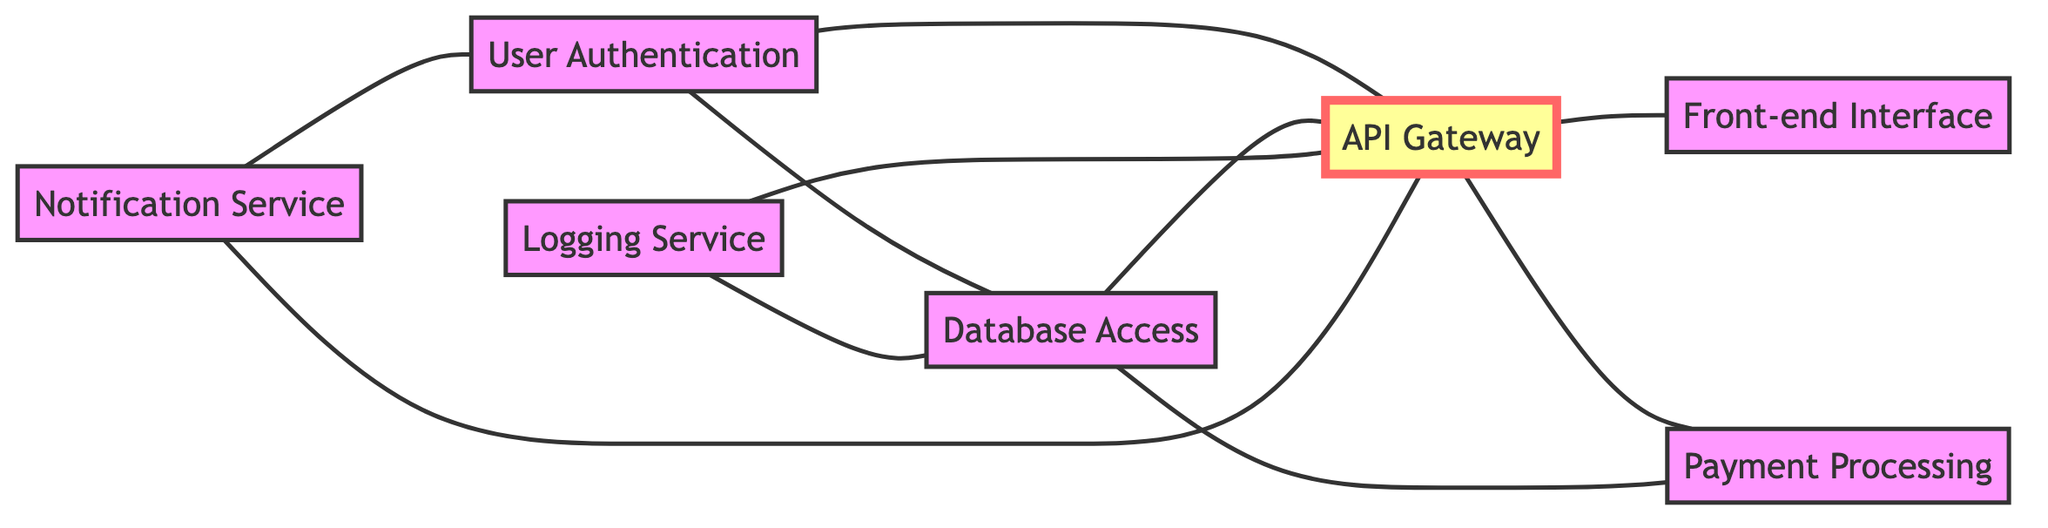What is the total number of nodes in the diagram? By counting the nodes listed in the data, we see that there are seven distinct modules: User Authentication, Database Access, API Gateway, Front-end Interface, Payment Processing, Logging Service, and Notification Service. Therefore, the total number of nodes is 7.
Answer: 7 Which module does the API Gateway connect to directly? Inspecting the connected edges to the API Gateway (ModuleC), we can see it connects directly to User Authentication (ModuleA), Database Access (ModuleB), Front-end Interface (ModuleD), Payment Processing (ModuleE), and Notification Service (ModuleG). Therefore, the direct connections are with ModuleA, ModuleB, ModuleD, ModuleE, and ModuleG.
Answer: ModuleA, ModuleB, ModuleD, ModuleE, ModuleG How many edges are connected to the Database Access module? Looking at the edges connected to Database Access (ModuleB), we have: User Authentication (ModuleA), API Gateway (ModuleC), and Payment Processing (ModuleE) connected to it. So, counting these edges gives us a total of 4 connections.
Answer: 4 Which module does the Notification Service depend on? The Notification Service (ModuleG) is connected to User Authentication (ModuleA) and API Gateway (ModuleC). Thus, it depends directly on both User Authentication and API Gateway.
Answer: User Authentication, API Gateway Identify the module that has the highest number of dependencies. Analyzing the connections, the API Gateway (ModuleC) has links to User Authentication (ModuleA), Database Access (ModuleB), Front-end Interface (ModuleD), Payment Processing (ModuleE), and Logging Service (ModuleF), resulting in a total of 5 dependencies. No other module has more connections.
Answer: API Gateway Which module is a prerequisite for Payment Processing? The edges indicate that Payment Processing (ModuleE) has a direct connection to Database Access (ModuleB), which implies that Payment Processing depends on the Database Access module.
Answer: Database Access How many modules are directly dependent on the Logging Service? From the edges connected to Logging Service (ModuleF), we observe it connects to Database Access (ModuleB) and API Gateway (ModuleC). Since there are two connections, the number of modules directly dependent on Logging Service is 2.
Answer: 2 What is the relationship between User Authentication and Notification Service? The edges reveal that User Authentication (ModuleA) is connected to Notification Service (ModuleG), indicating a direct relationship between the two modules.
Answer: Direct connection 